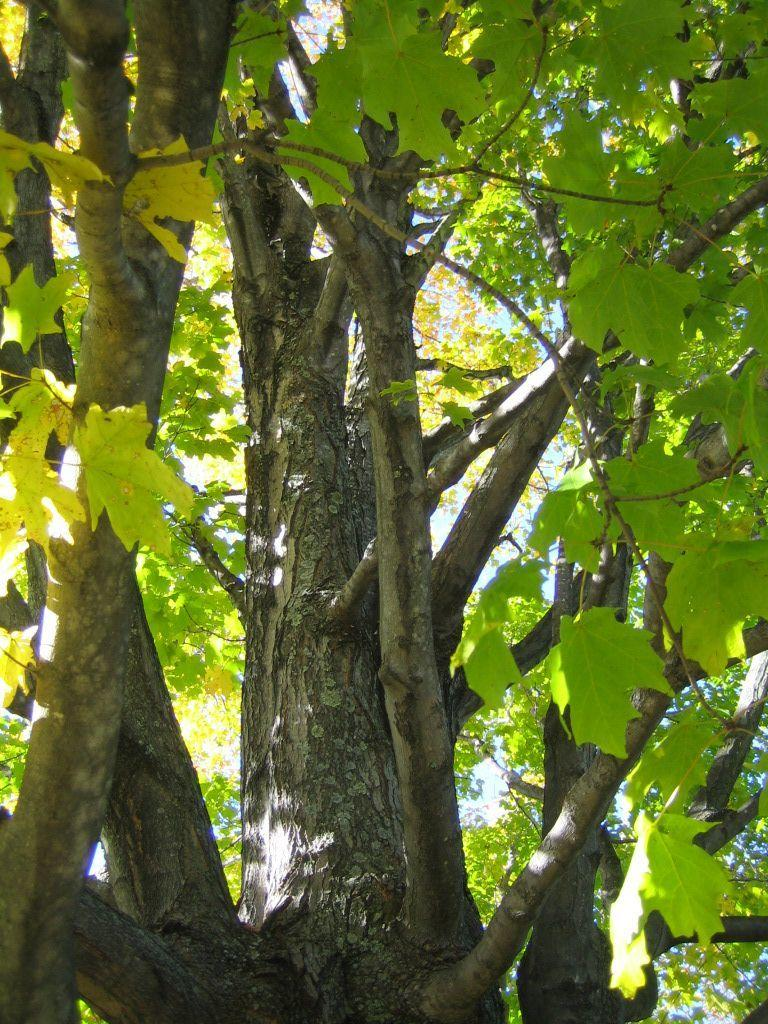What type of vegetation is visible in the front of the image? There are trees in the front of the image. What part of the natural environment is visible in the background of the image? The sky is visible in the background of the image. How many clovers can be seen growing among the trees in the image? There is no mention of clovers in the image, so it is not possible to determine how many might be present. 